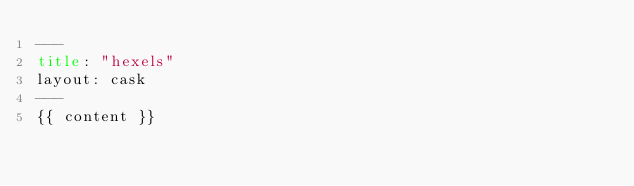<code> <loc_0><loc_0><loc_500><loc_500><_HTML_>---
title: "hexels"
layout: cask
---
{{ content }}
</code> 